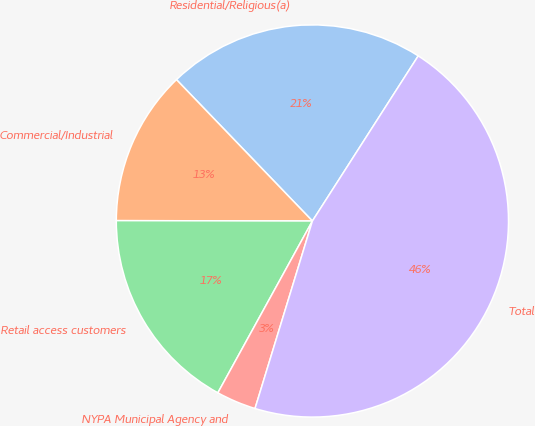Convert chart. <chart><loc_0><loc_0><loc_500><loc_500><pie_chart><fcel>Residential/Religious(a)<fcel>Commercial/Industrial<fcel>Retail access customers<fcel>NYPA Municipal Agency and<fcel>Total<nl><fcel>21.26%<fcel>12.78%<fcel>17.02%<fcel>3.28%<fcel>45.65%<nl></chart> 